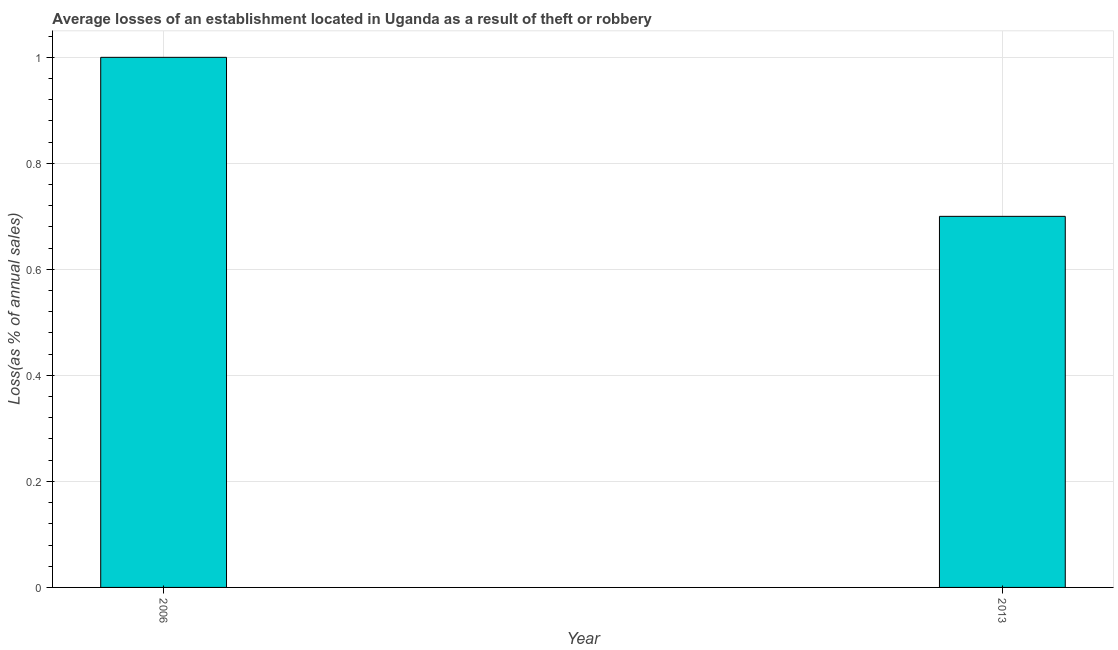Does the graph contain any zero values?
Keep it short and to the point. No. What is the title of the graph?
Keep it short and to the point. Average losses of an establishment located in Uganda as a result of theft or robbery. What is the label or title of the X-axis?
Your answer should be compact. Year. What is the label or title of the Y-axis?
Give a very brief answer. Loss(as % of annual sales). What is the losses due to theft in 2013?
Keep it short and to the point. 0.7. Across all years, what is the minimum losses due to theft?
Your answer should be very brief. 0.7. In which year was the losses due to theft minimum?
Make the answer very short. 2013. What is the sum of the losses due to theft?
Your answer should be compact. 1.7. What is the median losses due to theft?
Make the answer very short. 0.85. Do a majority of the years between 2006 and 2013 (inclusive) have losses due to theft greater than 0.4 %?
Your response must be concise. Yes. What is the ratio of the losses due to theft in 2006 to that in 2013?
Provide a short and direct response. 1.43. Is the losses due to theft in 2006 less than that in 2013?
Provide a succinct answer. No. How many years are there in the graph?
Your answer should be compact. 2. Are the values on the major ticks of Y-axis written in scientific E-notation?
Your answer should be very brief. No. What is the Loss(as % of annual sales) in 2006?
Provide a short and direct response. 1. What is the Loss(as % of annual sales) in 2013?
Keep it short and to the point. 0.7. What is the ratio of the Loss(as % of annual sales) in 2006 to that in 2013?
Give a very brief answer. 1.43. 